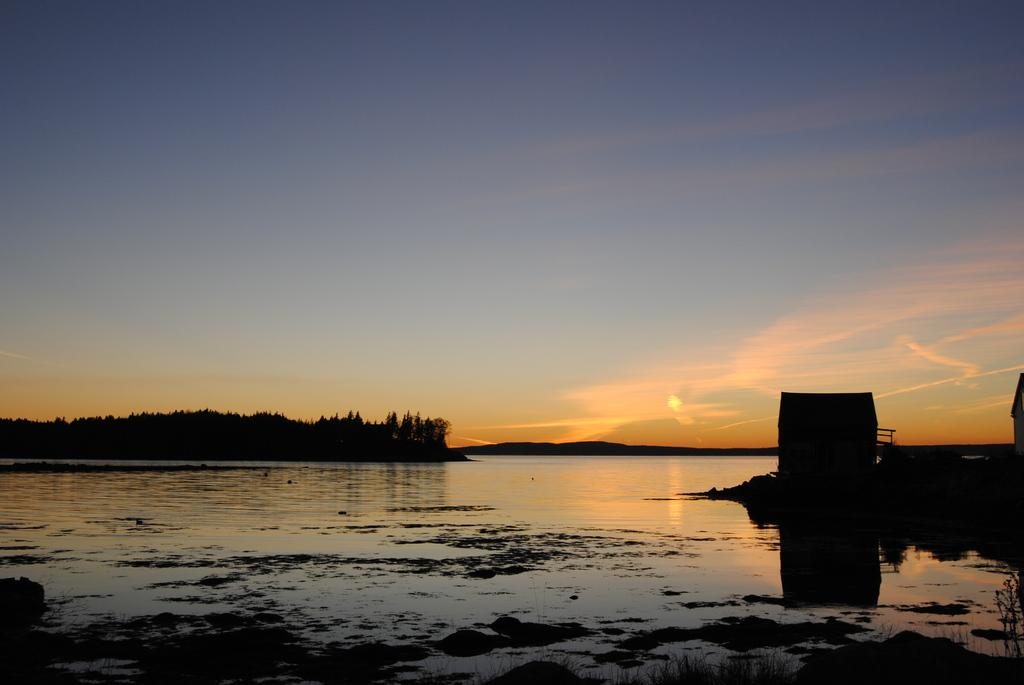What is the main element present in the image? There is water in the image. What other natural elements can be seen in the image? There are trees in the image. What is the condition of the sky in the image? The sun is visible in the sky. What type of structure is visible on the right side of the image? There appears to be a house on the right side of the image. Can you describe the small room visible in the image? There is a small room visible in the image. What type of leather is used to make the swing in the image? There is no swing present in the image, so leather cannot be used to make a swing in this context. 